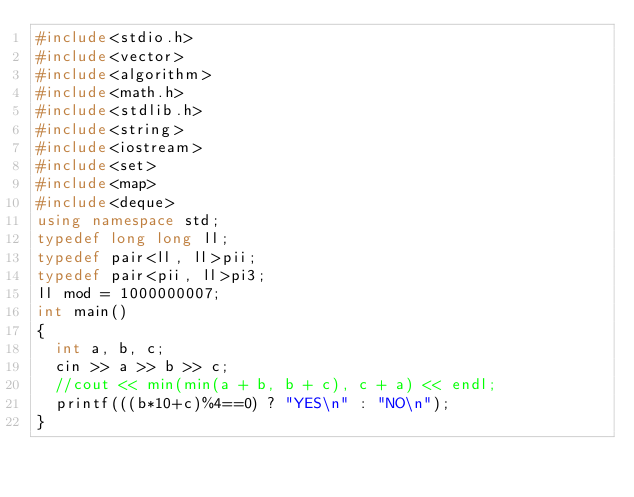Convert code to text. <code><loc_0><loc_0><loc_500><loc_500><_C++_>#include<stdio.h>
#include<vector>
#include<algorithm>
#include<math.h>
#include<stdlib.h>
#include<string>
#include<iostream>
#include<set>
#include<map>
#include<deque>
using namespace std;
typedef long long ll;
typedef pair<ll, ll>pii;
typedef pair<pii, ll>pi3;
ll mod = 1000000007;
int main()
{
	int a, b, c;
	cin >> a >> b >> c;
	//cout << min(min(a + b, b + c), c + a) << endl;
	printf(((b*10+c)%4==0) ? "YES\n" : "NO\n");
}</code> 